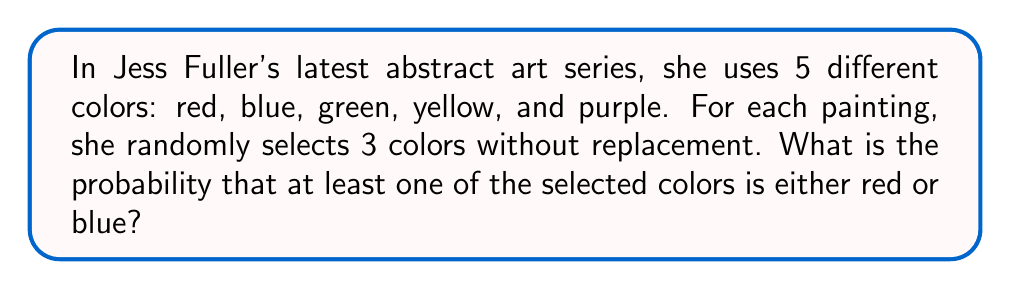Solve this math problem. Let's approach this step-by-step:

1) First, we need to calculate the total number of possible color combinations. This is a combination problem where we are selecting 3 colors out of 5 without replacement and order doesn't matter. We can calculate this using the combination formula:

   $$\binom{5}{3} = \frac{5!}{3!(5-3)!} = \frac{5 \cdot 4 \cdot 3}{3 \cdot 2 \cdot 1} = 10$$

2) Now, let's consider the opposite event: the probability of selecting 3 colors that are neither red nor blue. This means we're selecting 3 colors out of the remaining 3 colors (green, yellow, purple).

3) The number of ways to select 3 colors out of 3 is:

   $$\binom{3}{3} = 1$$

4) So, the probability of not selecting either red or blue is:

   $$P(\text{no red or blue}) = \frac{1}{10} = 0.1$$

5) Therefore, the probability of selecting at least one red or blue color is the complement of this probability:

   $$P(\text{at least one red or blue}) = 1 - P(\text{no red or blue}) = 1 - 0.1 = 0.9$$

6) We can also verify this directly:
   - Probability of selecting red = $\frac{5}{5} \cdot \frac{4}{4} \cdot \frac{3}{3} - \frac{4}{5} \cdot \frac{3}{4} \cdot \frac{2}{3} = 1 - 0.4 = 0.6$
   - Probability of selecting blue (given red wasn't selected) = $0.4 \cdot \frac{4}{4} \cdot \frac{3}{3} - 0.4 \cdot \frac{3}{4} \cdot \frac{2}{3} = 0.4 - 0.2 = 0.2$
   - Probability of selecting blue (given red was selected) = $0.6 \cdot \frac{4}{4} \cdot \frac{1}{3} = 0.2$

   Total probability = $0.6 + 0.2 + 0.1 = 0.9$
Answer: 0.9 